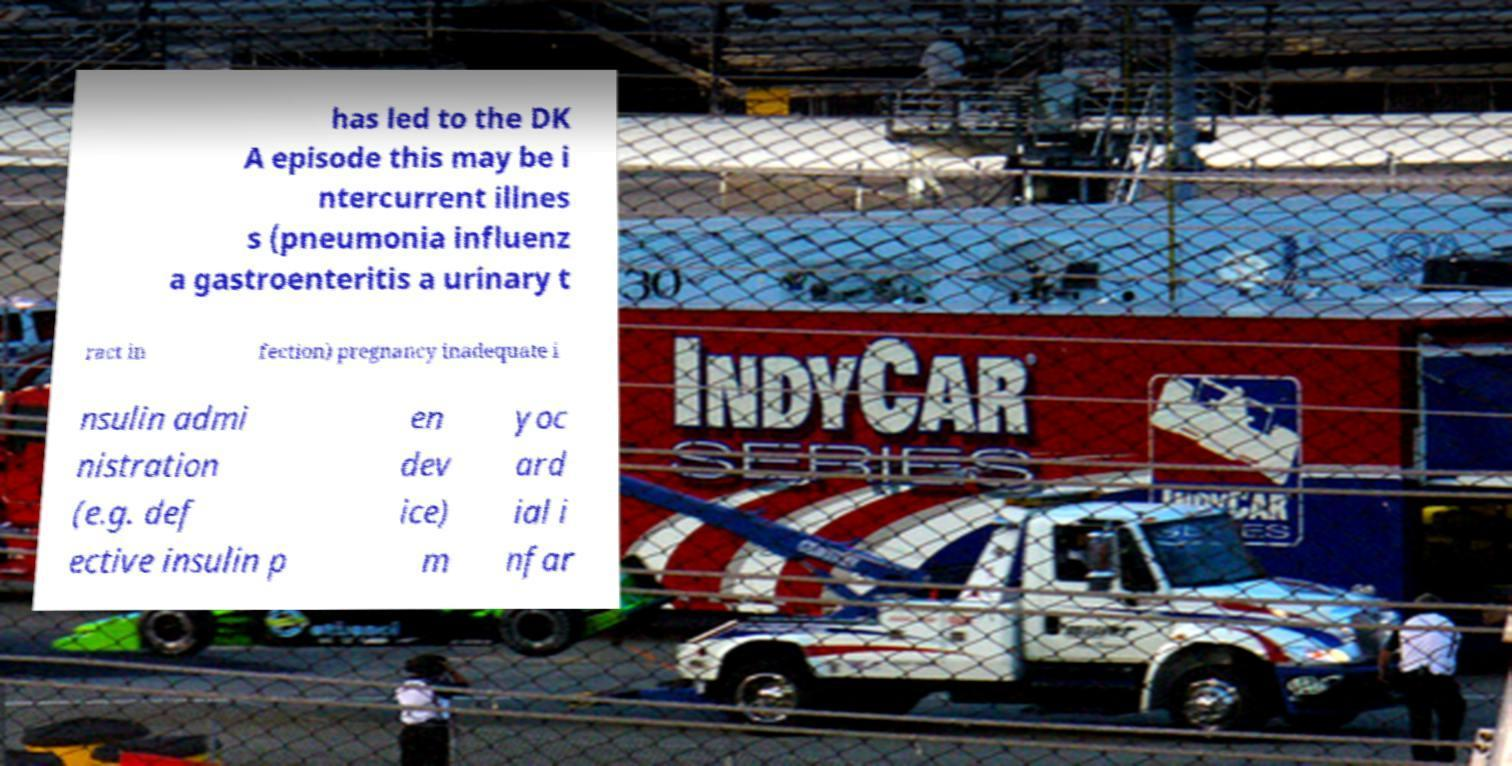Could you assist in decoding the text presented in this image and type it out clearly? has led to the DK A episode this may be i ntercurrent illnes s (pneumonia influenz a gastroenteritis a urinary t ract in fection) pregnancy inadequate i nsulin admi nistration (e.g. def ective insulin p en dev ice) m yoc ard ial i nfar 